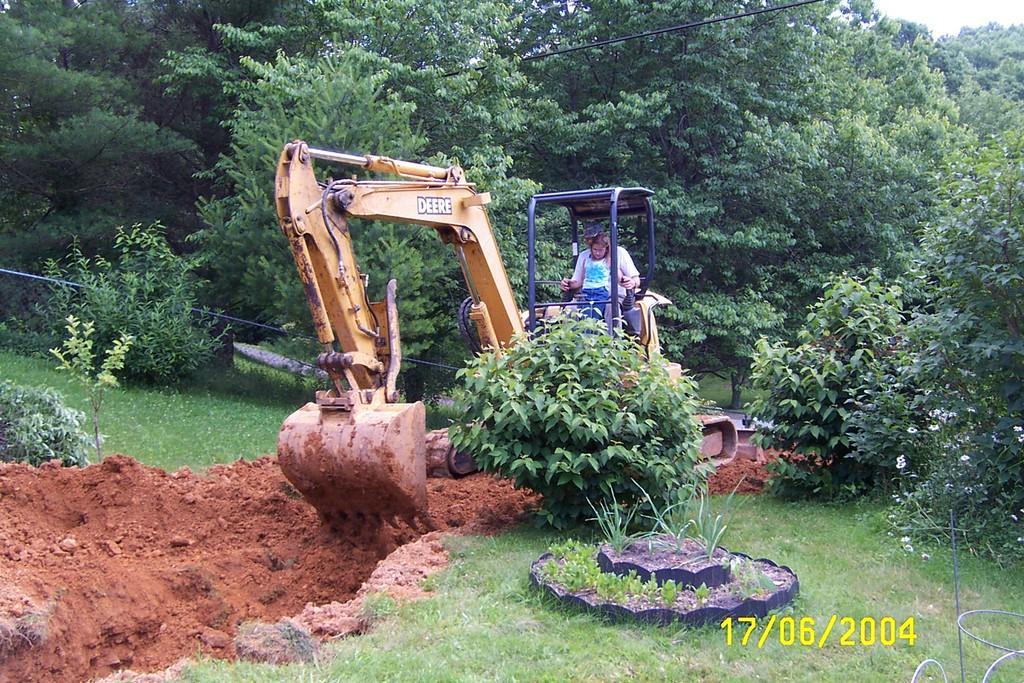How would you summarize this image in a sentence or two? This image is taken outdoors. At the bottom of the image there is a ground with grass and a few plants on it. In the background there are many trees and plants. In the middle of the image there is a crane to dig the ground. There is a man in the crane. 